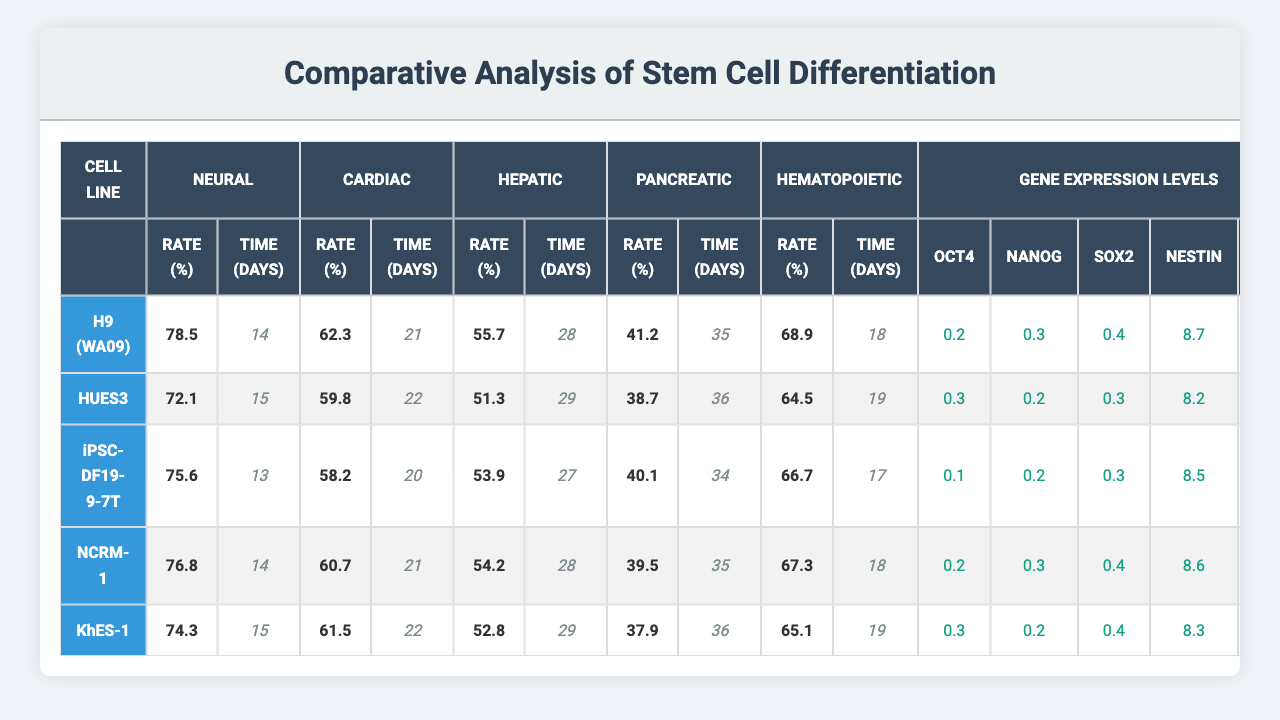What is the differentiation rate for H9 (WA09) in the Neural pathway? The table shows the differentiation rate for H9 (WA09) under the Neural pathway as 78.5%.
Answer: 78.5% Which cell line has the highest differentiation rate in the Cardiac pathway? By comparing the differentiation rates in the Cardiac pathway across all cell lines, H9 (WA09) has the highest rate at 62.3%.
Answer: H9 (WA09) What is the differentiation time for iPSC-DF19-9-7T in the Hepatic pathway? Looking at the differentiation time for iPSC-DF19-9-7T, it takes 27 days for the Hepatic pathway.
Answer: 27 days Is the differentiation rate for KhES-1 in the Pancreatic pathway above 40%? The differentiation rate for KhES-1 in the Pancreatic pathway is 37.9%, which is below 40%.
Answer: No What is the average differentiation rate for Hematopoietic across all cell lines? Adding the Hematopoietic rates: 68.9 + 64.5 + 66.7 + 67.3 + 65.1 = 332.5. Dividing by the number of cell lines (5) gives an average of 332.5/5 = 66.5%.
Answer: 66.5% How does the differentiation rate in the Neural pathway for NCRM-1 compare to that of HUES3? The Neural pathway differentiation rate for NCRM-1 is 76.8%, while for HUES3 it is 72.1%. NCRM-1 has a higher rate by 4.7%.
Answer: NCRM-1 is higher by 4.7% Which gene has the highest expression level in H9 (WA09)? The gene expression levels for H9 (WA09) indicate that NESTIN has the highest value at 8.7.
Answer: NESTIN What is the differentiation time for the Cardiac pathway in HUES3 and how does it compare to the differentiation time for Neural in the same cell line? HUES3 has a differentiation time of 22 days for the Cardiac pathway and 15 days for the Neural pathway. Cardiac takes 7 days longer than Neural.
Answer: Cardiac takes 7 days longer Which cell line exhibits the lowest gene expression of NANOG? Examining the gene expression levels, iPSC-DF19-9-7T has the lowest expression level of NANOG at 0.2.
Answer: iPSC-DF19-9-7T If you consider both rate and time for differentiation in the Hepatic pathway, which cell line has the best performance overall? H9 (WA09) has a rate of 55.7% in 28 days, HUES3 has 51.3% in 29 days, iPSC-DF19-9-7T has 53.9% in 27 days, NCRM-1 has 54.2% in 28 days, and KhES-1 has 52.8% in 29 days. The iPSC-DF19-9-7T has the highest rate (53.9%) and lowest time (27 days) among them.
Answer: iPSC-DF19-9-7T What is the differentiation rate difference between Neural and Hepatic pathways for the H9 (WA09) cell line? The differentiation rate for Neural in H9 (WA09) is 78.5% and for Hepatic is 55.7%, resulting in a difference of 78.5% - 55.7% = 22.8%.
Answer: 22.8% 